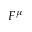<formula> <loc_0><loc_0><loc_500><loc_500>F ^ { \mu }</formula> 